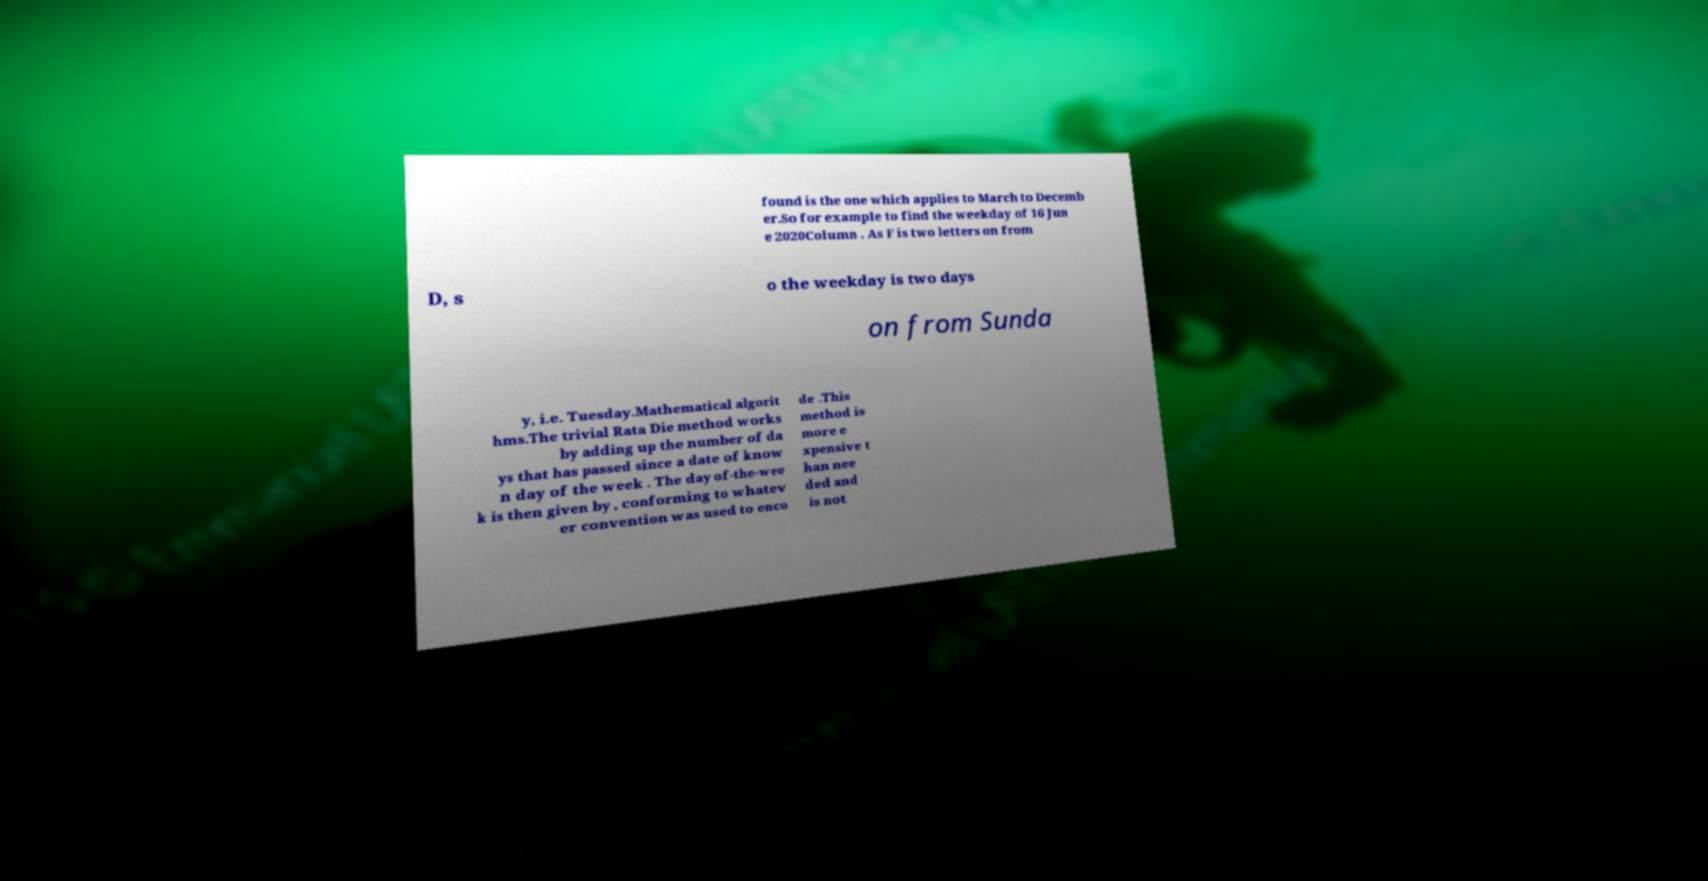I need the written content from this picture converted into text. Can you do that? found is the one which applies to March to Decemb er.So for example to find the weekday of 16 Jun e 2020Column . As F is two letters on from D, s o the weekday is two days on from Sunda y, i.e. Tuesday.Mathematical algorit hms.The trivial Rata Die method works by adding up the number of da ys that has passed since a date of know n day of the week . The day of-the-wee k is then given by , conforming to whatev er convention was used to enco de .This method is more e xpensive t han nee ded and is not 